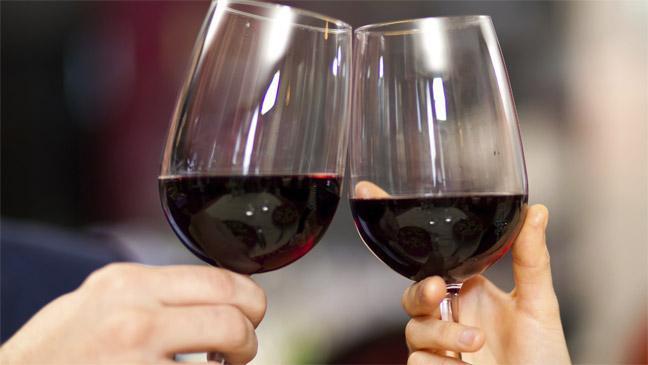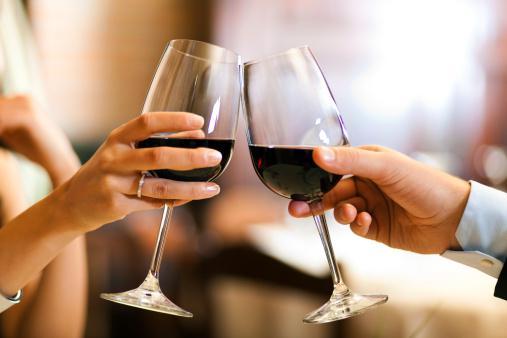The first image is the image on the left, the second image is the image on the right. For the images displayed, is the sentence "At least one image has a flame or candle in the background." factually correct? Answer yes or no. No. The first image is the image on the left, the second image is the image on the right. For the images displayed, is the sentence "No hands are holding the wine glasses in the right-hand image." factually correct? Answer yes or no. No. 